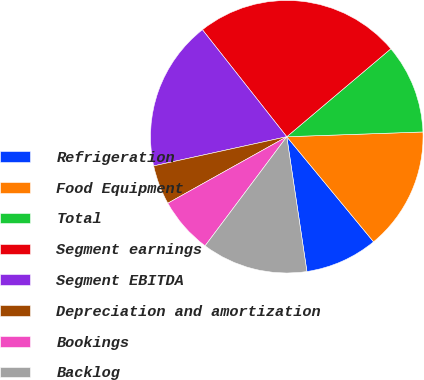<chart> <loc_0><loc_0><loc_500><loc_500><pie_chart><fcel>Refrigeration<fcel>Food Equipment<fcel>Total<fcel>Segment earnings<fcel>Segment EBITDA<fcel>Depreciation and amortization<fcel>Bookings<fcel>Backlog<nl><fcel>8.63%<fcel>14.57%<fcel>10.61%<fcel>24.46%<fcel>17.81%<fcel>4.68%<fcel>6.66%<fcel>12.59%<nl></chart> 